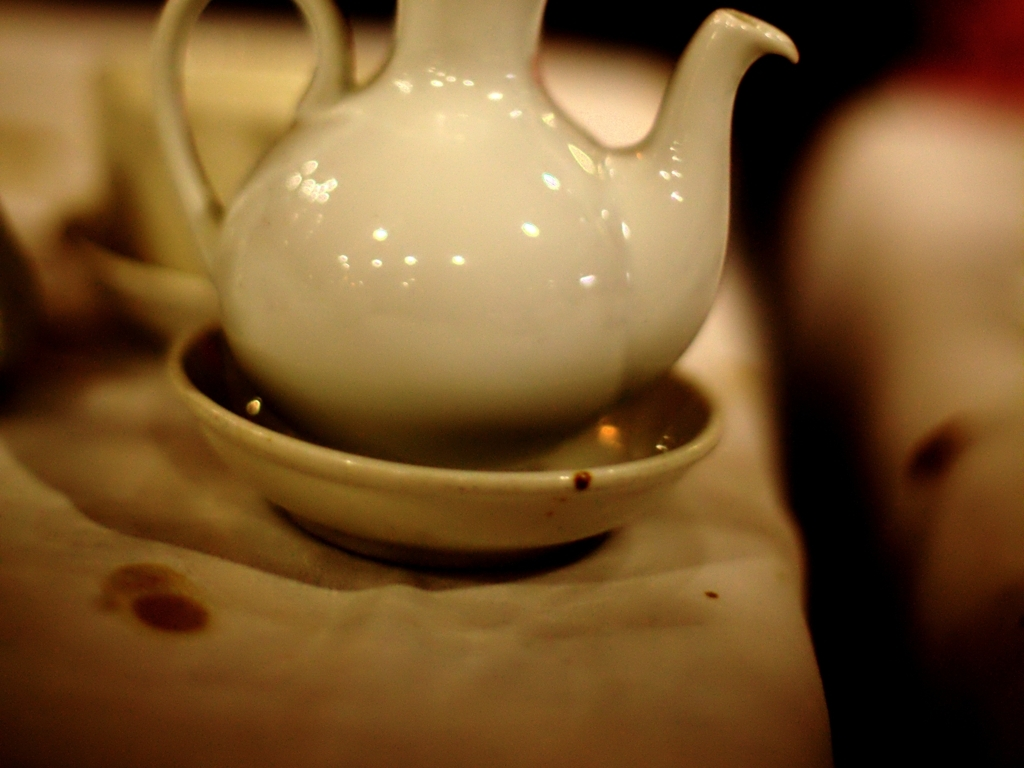What mood does this image evoke? The image evokes a sense of intimacy and calmness, potentially reminding one of quiet moments, such as enjoying a warm beverage alone or with a close companion. 